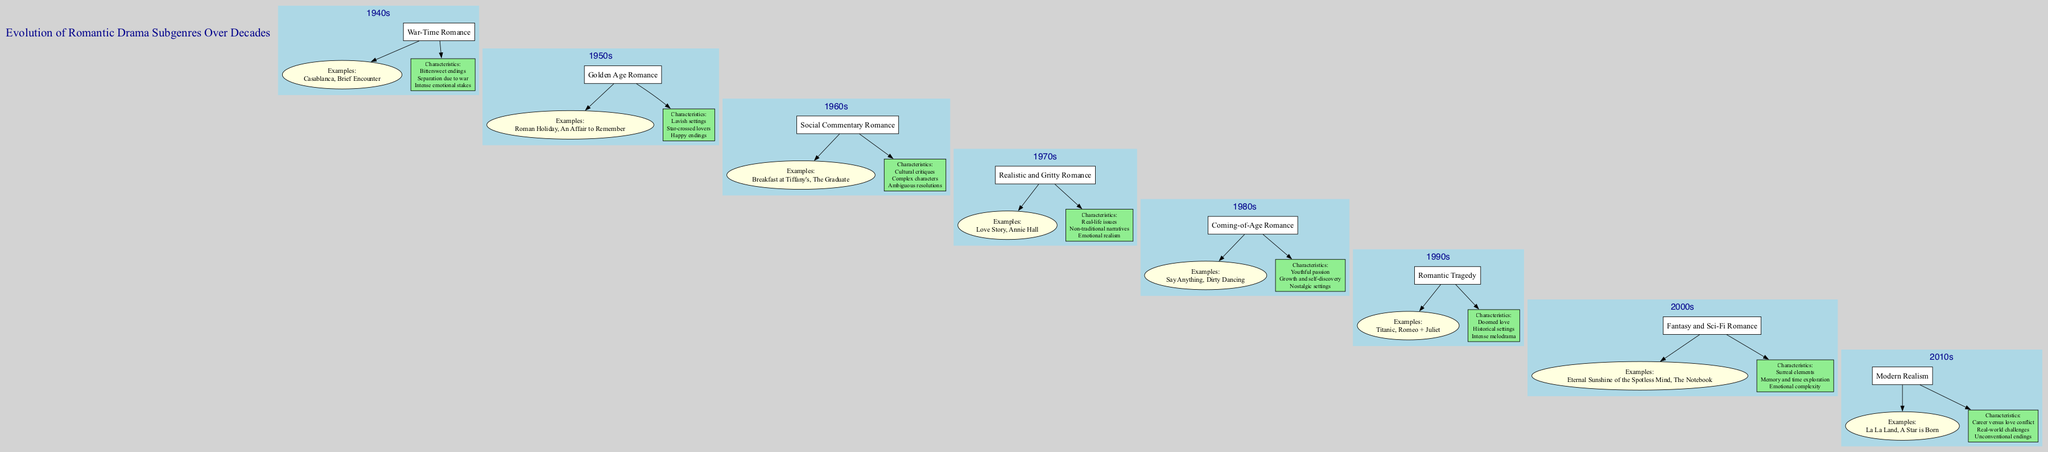What subgenre of romantic drama is associated with the 1990s? By looking at the box node for the 1990s, the subgenre "Romantic Tragedy" is directly stated there.
Answer: Romantic Tragedy How many subgenres are there in total in the diagram? By counting each decade's subgenre listed from the 1940s to the 2010s, we find a total of 8 distinct subgenres.
Answer: 8 What is a characteristic of the War-Time Romance subgenre? The characteristics listed under the War-Time Romance node include "Bittersweet endings", "Separation due to war", and "Intense emotional stakes". Any of these are valid, but "Bittersweet endings" is one specific example.
Answer: Bittersweet endings Name an example film from the 2000s subgenre. In the examples node under the 2000s, "Eternal Sunshine of the Spotless Mind" is one of the films listed.
Answer: Eternal Sunshine of the Spotless Mind What decade is associated with the characteristics of "Careers versus love conflict"? This characteristic is found under the subgenre of "Modern Realism", which is associated with the 2010s as indicated in the diagram.
Answer: 2010s Which subgenre features "Doomed love"? Looking at the characteristics that are listed for the 1990s, "Doomed love" is specifically mentioned for the subgenre "Romantic Tragedy".
Answer: Romantic Tragedy How does the subgenre of the 1980s relate to the 1970s? The diagram shows a directed edge from the 1970s subgenre ("Realistic and Gritty Romance") to the 1980s subgenre ("Coming-of-Age Romance"), indicating a progression in themes.
Answer: Progression in themes What unique aspect differentiates Social Commentary Romance from War-Time Romance? "Social Commentary Romance" includes "Cultural critiques" among its characteristics, while "War-Time Romance" focuses on "Separation due to war", showcasing different thematic focuses.
Answer: Thematic focuses 